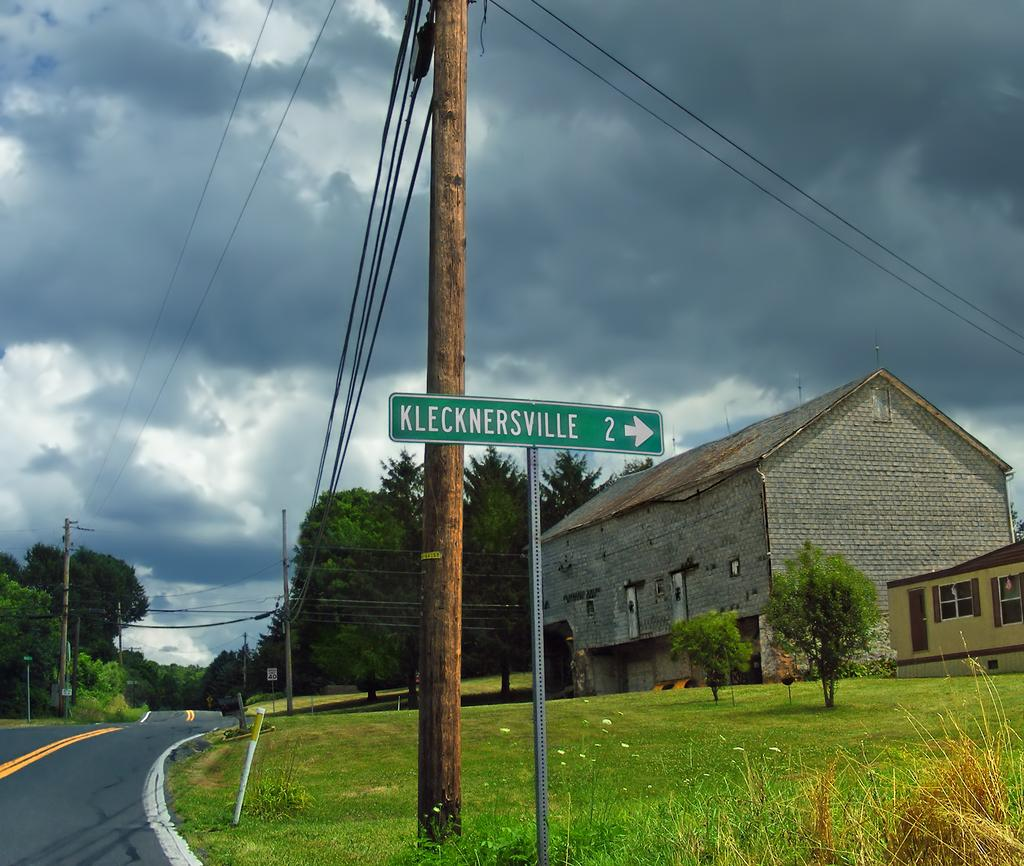What structures can be seen in the image? There are poles, boards, and houses visible in the image. What type of natural environment is present in the image? There is grass and trees in the image. What man-made structures can be seen in the image? There are wires and a road visible in the image. What is visible in the background of the image? The sky is visible in the background of the image. What is the rate at which the stick is being used in the image? There is no stick present in the image, so it is not possible to determine the rate at which it might be used. What is the edge of the image used for? The edge of the image is not a part of the scene being depicted; it is simply the boundary of the photograph or illustration. 